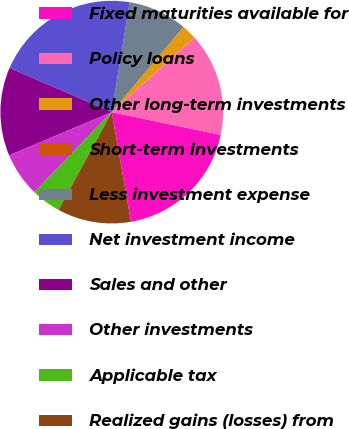Convert chart. <chart><loc_0><loc_0><loc_500><loc_500><pie_chart><fcel>Fixed maturities available for<fcel>Policy loans<fcel>Other long-term investments<fcel>Short-term investments<fcel>Less investment expense<fcel>Net investment income<fcel>Sales and other<fcel>Other investments<fcel>Applicable tax<fcel>Realized gains (losses) from<nl><fcel>18.95%<fcel>14.97%<fcel>2.16%<fcel>0.02%<fcel>8.56%<fcel>21.09%<fcel>12.83%<fcel>6.43%<fcel>4.29%<fcel>10.7%<nl></chart> 